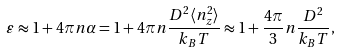<formula> <loc_0><loc_0><loc_500><loc_500>\varepsilon & \approx 1 + 4 \pi n \alpha = 1 + 4 \pi n \frac { D ^ { 2 } \langle n _ { z } ^ { 2 } \rangle } { k _ { B } T } \approx 1 + \frac { 4 \pi } { 3 } n \frac { D ^ { 2 } } { k _ { B } T } ,</formula> 